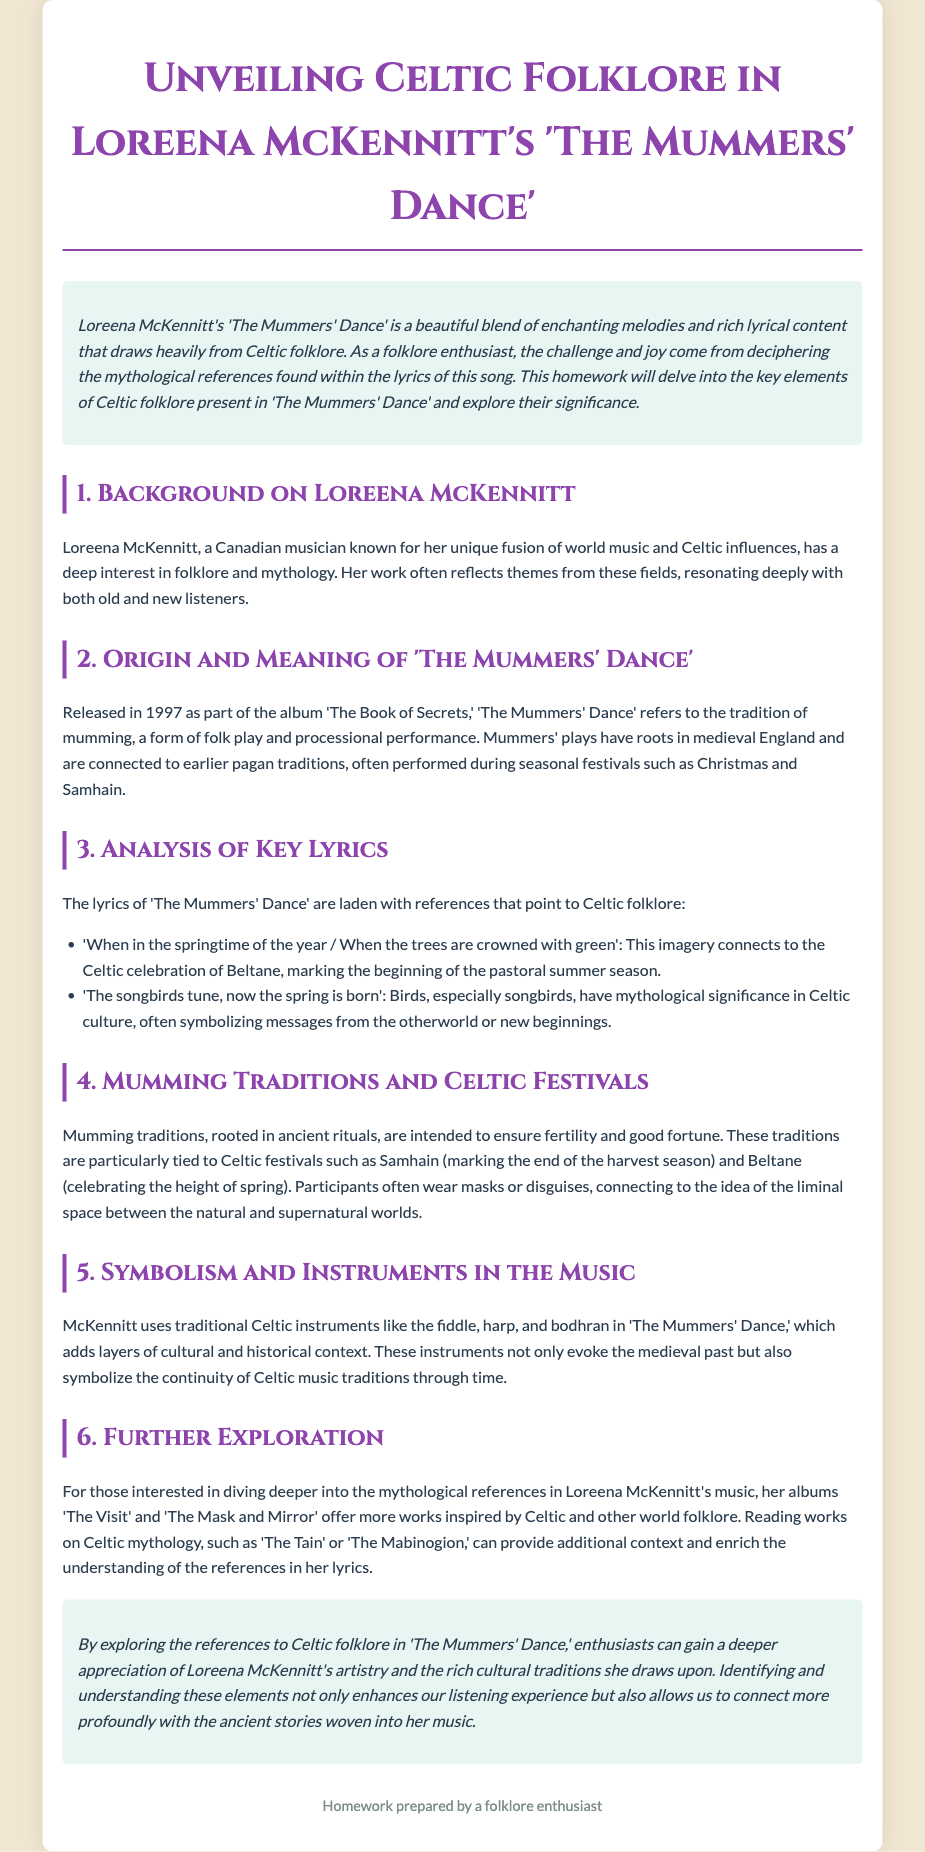What year was 'The Mummers' Dance' released? The release year is specified in the document as part of the album details.
Answer: 1997 What traditional folk performance does 'The Mummers' Dance' refer to? The document mentions that 'The Mummers' Dance' refers to the tradition of mumming.
Answer: Mumming What seasonal festival is associated with the phrase "When the trees are crowned with green"? The document connects this imagery to the Celtic celebration mentioned.
Answer: Beltane Which two Celtic festivals are tied to mumming traditions? Two specific festivals are noted as connected to mumming traditions in the document.
Answer: Samhain and Beltane What instruments are mentioned as being used in 'The Mummers' Dance'? The document lists traditional instruments used in the music of 'The Mummers' Dance.'
Answer: Fiddle, harp, and bodhran Who is Loreena McKennitt? The document provides a brief introduction to her background and interests.
Answer: A Canadian musician What additional albums are suggested for further exploration of mythological references? The document names two albums that contain more works inspired by Celtic folklore.
Answer: The Visit and The Mask and Mirror What mythological significance do songbirds have in Celtic culture? The document describes the symbolism associated with songbirds in the context provided.
Answer: Messages from the otherworld What is the genre of music combined in Loreena McKennitt's work? The document refers to the unique style of her music in a specific phrase.
Answer: World music and Celtic influences 